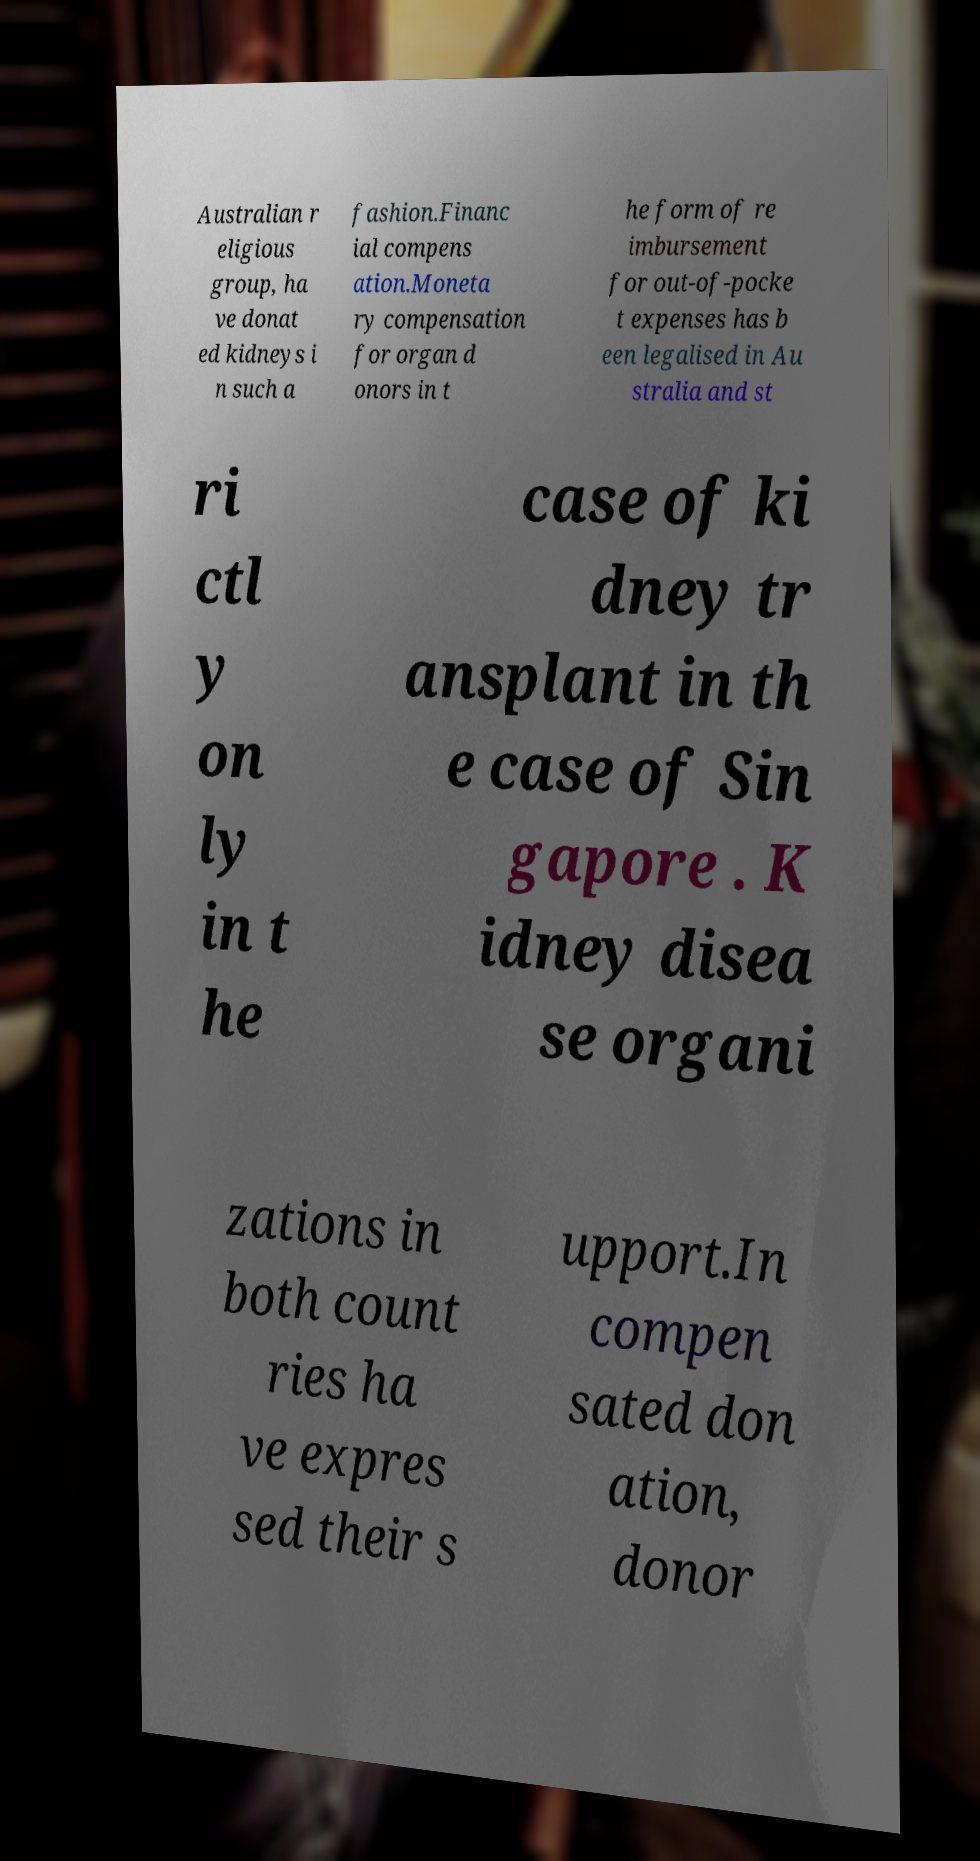Can you read and provide the text displayed in the image?This photo seems to have some interesting text. Can you extract and type it out for me? Australian r eligious group, ha ve donat ed kidneys i n such a fashion.Financ ial compens ation.Moneta ry compensation for organ d onors in t he form of re imbursement for out-of-pocke t expenses has b een legalised in Au stralia and st ri ctl y on ly in t he case of ki dney tr ansplant in th e case of Sin gapore . K idney disea se organi zations in both count ries ha ve expres sed their s upport.In compen sated don ation, donor 